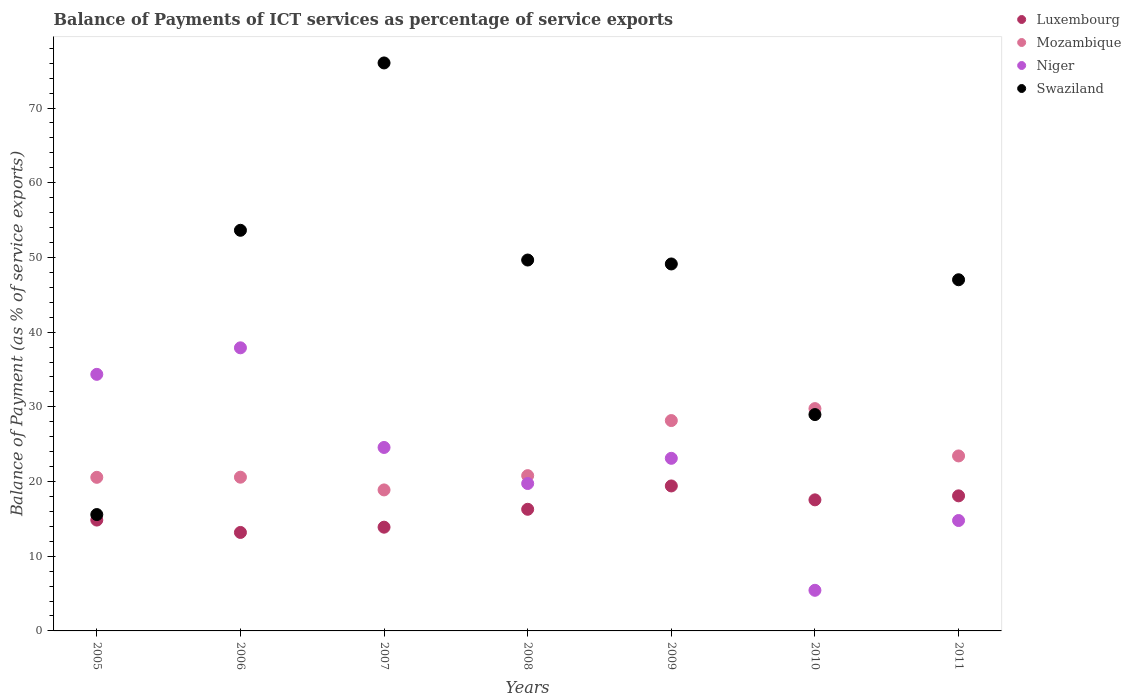What is the balance of payments of ICT services in Mozambique in 2005?
Your answer should be compact. 20.56. Across all years, what is the maximum balance of payments of ICT services in Niger?
Your answer should be very brief. 37.9. Across all years, what is the minimum balance of payments of ICT services in Mozambique?
Offer a terse response. 18.88. In which year was the balance of payments of ICT services in Swaziland minimum?
Ensure brevity in your answer.  2005. What is the total balance of payments of ICT services in Swaziland in the graph?
Ensure brevity in your answer.  319.99. What is the difference between the balance of payments of ICT services in Niger in 2008 and that in 2009?
Offer a terse response. -3.37. What is the difference between the balance of payments of ICT services in Luxembourg in 2011 and the balance of payments of ICT services in Swaziland in 2009?
Your answer should be very brief. -31.04. What is the average balance of payments of ICT services in Mozambique per year?
Offer a terse response. 23.16. In the year 2005, what is the difference between the balance of payments of ICT services in Luxembourg and balance of payments of ICT services in Mozambique?
Keep it short and to the point. -5.72. What is the ratio of the balance of payments of ICT services in Mozambique in 2006 to that in 2010?
Provide a short and direct response. 0.69. Is the difference between the balance of payments of ICT services in Luxembourg in 2006 and 2007 greater than the difference between the balance of payments of ICT services in Mozambique in 2006 and 2007?
Make the answer very short. No. What is the difference between the highest and the second highest balance of payments of ICT services in Mozambique?
Offer a terse response. 1.6. What is the difference between the highest and the lowest balance of payments of ICT services in Mozambique?
Offer a terse response. 10.88. Is the sum of the balance of payments of ICT services in Luxembourg in 2006 and 2009 greater than the maximum balance of payments of ICT services in Mozambique across all years?
Offer a terse response. Yes. Is it the case that in every year, the sum of the balance of payments of ICT services in Mozambique and balance of payments of ICT services in Luxembourg  is greater than the balance of payments of ICT services in Niger?
Your response must be concise. No. Does the balance of payments of ICT services in Swaziland monotonically increase over the years?
Offer a very short reply. No. How many dotlines are there?
Provide a succinct answer. 4. How many years are there in the graph?
Keep it short and to the point. 7. What is the difference between two consecutive major ticks on the Y-axis?
Your response must be concise. 10. Does the graph contain any zero values?
Your answer should be compact. No. Where does the legend appear in the graph?
Make the answer very short. Top right. How many legend labels are there?
Provide a succinct answer. 4. What is the title of the graph?
Give a very brief answer. Balance of Payments of ICT services as percentage of service exports. Does "Iran" appear as one of the legend labels in the graph?
Your response must be concise. No. What is the label or title of the X-axis?
Make the answer very short. Years. What is the label or title of the Y-axis?
Offer a terse response. Balance of Payment (as % of service exports). What is the Balance of Payment (as % of service exports) in Luxembourg in 2005?
Offer a very short reply. 14.84. What is the Balance of Payment (as % of service exports) in Mozambique in 2005?
Your response must be concise. 20.56. What is the Balance of Payment (as % of service exports) in Niger in 2005?
Your answer should be compact. 34.35. What is the Balance of Payment (as % of service exports) in Swaziland in 2005?
Provide a succinct answer. 15.58. What is the Balance of Payment (as % of service exports) in Luxembourg in 2006?
Provide a short and direct response. 13.18. What is the Balance of Payment (as % of service exports) of Mozambique in 2006?
Ensure brevity in your answer.  20.58. What is the Balance of Payment (as % of service exports) in Niger in 2006?
Ensure brevity in your answer.  37.9. What is the Balance of Payment (as % of service exports) of Swaziland in 2006?
Offer a very short reply. 53.63. What is the Balance of Payment (as % of service exports) of Luxembourg in 2007?
Provide a short and direct response. 13.89. What is the Balance of Payment (as % of service exports) of Mozambique in 2007?
Make the answer very short. 18.88. What is the Balance of Payment (as % of service exports) of Niger in 2007?
Make the answer very short. 24.56. What is the Balance of Payment (as % of service exports) of Swaziland in 2007?
Your response must be concise. 76.03. What is the Balance of Payment (as % of service exports) of Luxembourg in 2008?
Keep it short and to the point. 16.28. What is the Balance of Payment (as % of service exports) of Mozambique in 2008?
Keep it short and to the point. 20.79. What is the Balance of Payment (as % of service exports) of Niger in 2008?
Offer a terse response. 19.73. What is the Balance of Payment (as % of service exports) of Swaziland in 2008?
Keep it short and to the point. 49.65. What is the Balance of Payment (as % of service exports) in Luxembourg in 2009?
Ensure brevity in your answer.  19.41. What is the Balance of Payment (as % of service exports) of Mozambique in 2009?
Make the answer very short. 28.16. What is the Balance of Payment (as % of service exports) of Niger in 2009?
Make the answer very short. 23.11. What is the Balance of Payment (as % of service exports) in Swaziland in 2009?
Give a very brief answer. 49.12. What is the Balance of Payment (as % of service exports) of Luxembourg in 2010?
Your response must be concise. 17.55. What is the Balance of Payment (as % of service exports) of Mozambique in 2010?
Ensure brevity in your answer.  29.76. What is the Balance of Payment (as % of service exports) in Niger in 2010?
Give a very brief answer. 5.44. What is the Balance of Payment (as % of service exports) in Swaziland in 2010?
Your answer should be compact. 28.96. What is the Balance of Payment (as % of service exports) in Luxembourg in 2011?
Provide a succinct answer. 18.08. What is the Balance of Payment (as % of service exports) of Mozambique in 2011?
Keep it short and to the point. 23.43. What is the Balance of Payment (as % of service exports) in Niger in 2011?
Your answer should be compact. 14.78. What is the Balance of Payment (as % of service exports) of Swaziland in 2011?
Offer a terse response. 47.01. Across all years, what is the maximum Balance of Payment (as % of service exports) in Luxembourg?
Offer a very short reply. 19.41. Across all years, what is the maximum Balance of Payment (as % of service exports) of Mozambique?
Ensure brevity in your answer.  29.76. Across all years, what is the maximum Balance of Payment (as % of service exports) of Niger?
Keep it short and to the point. 37.9. Across all years, what is the maximum Balance of Payment (as % of service exports) in Swaziland?
Provide a succinct answer. 76.03. Across all years, what is the minimum Balance of Payment (as % of service exports) of Luxembourg?
Keep it short and to the point. 13.18. Across all years, what is the minimum Balance of Payment (as % of service exports) of Mozambique?
Offer a very short reply. 18.88. Across all years, what is the minimum Balance of Payment (as % of service exports) of Niger?
Provide a short and direct response. 5.44. Across all years, what is the minimum Balance of Payment (as % of service exports) in Swaziland?
Your answer should be very brief. 15.58. What is the total Balance of Payment (as % of service exports) of Luxembourg in the graph?
Provide a short and direct response. 113.23. What is the total Balance of Payment (as % of service exports) of Mozambique in the graph?
Your answer should be very brief. 162.15. What is the total Balance of Payment (as % of service exports) of Niger in the graph?
Your response must be concise. 159.86. What is the total Balance of Payment (as % of service exports) in Swaziland in the graph?
Offer a terse response. 319.99. What is the difference between the Balance of Payment (as % of service exports) in Luxembourg in 2005 and that in 2006?
Your answer should be compact. 1.66. What is the difference between the Balance of Payment (as % of service exports) in Mozambique in 2005 and that in 2006?
Give a very brief answer. -0.02. What is the difference between the Balance of Payment (as % of service exports) in Niger in 2005 and that in 2006?
Your answer should be very brief. -3.55. What is the difference between the Balance of Payment (as % of service exports) of Swaziland in 2005 and that in 2006?
Your answer should be compact. -38.05. What is the difference between the Balance of Payment (as % of service exports) in Luxembourg in 2005 and that in 2007?
Provide a succinct answer. 0.95. What is the difference between the Balance of Payment (as % of service exports) of Mozambique in 2005 and that in 2007?
Offer a very short reply. 1.69. What is the difference between the Balance of Payment (as % of service exports) of Niger in 2005 and that in 2007?
Provide a short and direct response. 9.79. What is the difference between the Balance of Payment (as % of service exports) in Swaziland in 2005 and that in 2007?
Make the answer very short. -60.46. What is the difference between the Balance of Payment (as % of service exports) in Luxembourg in 2005 and that in 2008?
Give a very brief answer. -1.44. What is the difference between the Balance of Payment (as % of service exports) in Mozambique in 2005 and that in 2008?
Keep it short and to the point. -0.22. What is the difference between the Balance of Payment (as % of service exports) of Niger in 2005 and that in 2008?
Your answer should be very brief. 14.61. What is the difference between the Balance of Payment (as % of service exports) of Swaziland in 2005 and that in 2008?
Provide a succinct answer. -34.07. What is the difference between the Balance of Payment (as % of service exports) of Luxembourg in 2005 and that in 2009?
Your answer should be compact. -4.57. What is the difference between the Balance of Payment (as % of service exports) of Mozambique in 2005 and that in 2009?
Make the answer very short. -7.6. What is the difference between the Balance of Payment (as % of service exports) in Niger in 2005 and that in 2009?
Offer a very short reply. 11.24. What is the difference between the Balance of Payment (as % of service exports) in Swaziland in 2005 and that in 2009?
Offer a very short reply. -33.55. What is the difference between the Balance of Payment (as % of service exports) of Luxembourg in 2005 and that in 2010?
Offer a terse response. -2.71. What is the difference between the Balance of Payment (as % of service exports) in Mozambique in 2005 and that in 2010?
Keep it short and to the point. -9.2. What is the difference between the Balance of Payment (as % of service exports) in Niger in 2005 and that in 2010?
Make the answer very short. 28.91. What is the difference between the Balance of Payment (as % of service exports) in Swaziland in 2005 and that in 2010?
Ensure brevity in your answer.  -13.38. What is the difference between the Balance of Payment (as % of service exports) of Luxembourg in 2005 and that in 2011?
Keep it short and to the point. -3.24. What is the difference between the Balance of Payment (as % of service exports) in Mozambique in 2005 and that in 2011?
Offer a terse response. -2.86. What is the difference between the Balance of Payment (as % of service exports) in Niger in 2005 and that in 2011?
Keep it short and to the point. 19.57. What is the difference between the Balance of Payment (as % of service exports) of Swaziland in 2005 and that in 2011?
Provide a short and direct response. -31.43. What is the difference between the Balance of Payment (as % of service exports) of Luxembourg in 2006 and that in 2007?
Your answer should be very brief. -0.7. What is the difference between the Balance of Payment (as % of service exports) of Mozambique in 2006 and that in 2007?
Offer a very short reply. 1.7. What is the difference between the Balance of Payment (as % of service exports) of Niger in 2006 and that in 2007?
Offer a very short reply. 13.34. What is the difference between the Balance of Payment (as % of service exports) in Swaziland in 2006 and that in 2007?
Offer a very short reply. -22.4. What is the difference between the Balance of Payment (as % of service exports) in Luxembourg in 2006 and that in 2008?
Give a very brief answer. -3.1. What is the difference between the Balance of Payment (as % of service exports) of Mozambique in 2006 and that in 2008?
Keep it short and to the point. -0.21. What is the difference between the Balance of Payment (as % of service exports) in Niger in 2006 and that in 2008?
Your response must be concise. 18.16. What is the difference between the Balance of Payment (as % of service exports) of Swaziland in 2006 and that in 2008?
Your answer should be very brief. 3.98. What is the difference between the Balance of Payment (as % of service exports) in Luxembourg in 2006 and that in 2009?
Keep it short and to the point. -6.22. What is the difference between the Balance of Payment (as % of service exports) of Mozambique in 2006 and that in 2009?
Give a very brief answer. -7.58. What is the difference between the Balance of Payment (as % of service exports) in Niger in 2006 and that in 2009?
Your answer should be very brief. 14.79. What is the difference between the Balance of Payment (as % of service exports) of Swaziland in 2006 and that in 2009?
Make the answer very short. 4.51. What is the difference between the Balance of Payment (as % of service exports) of Luxembourg in 2006 and that in 2010?
Give a very brief answer. -4.36. What is the difference between the Balance of Payment (as % of service exports) of Mozambique in 2006 and that in 2010?
Your answer should be compact. -9.18. What is the difference between the Balance of Payment (as % of service exports) of Niger in 2006 and that in 2010?
Provide a short and direct response. 32.46. What is the difference between the Balance of Payment (as % of service exports) of Swaziland in 2006 and that in 2010?
Make the answer very short. 24.67. What is the difference between the Balance of Payment (as % of service exports) in Luxembourg in 2006 and that in 2011?
Give a very brief answer. -4.9. What is the difference between the Balance of Payment (as % of service exports) of Mozambique in 2006 and that in 2011?
Keep it short and to the point. -2.85. What is the difference between the Balance of Payment (as % of service exports) of Niger in 2006 and that in 2011?
Provide a short and direct response. 23.12. What is the difference between the Balance of Payment (as % of service exports) of Swaziland in 2006 and that in 2011?
Your answer should be very brief. 6.62. What is the difference between the Balance of Payment (as % of service exports) in Luxembourg in 2007 and that in 2008?
Keep it short and to the point. -2.4. What is the difference between the Balance of Payment (as % of service exports) in Mozambique in 2007 and that in 2008?
Ensure brevity in your answer.  -1.91. What is the difference between the Balance of Payment (as % of service exports) in Niger in 2007 and that in 2008?
Provide a short and direct response. 4.83. What is the difference between the Balance of Payment (as % of service exports) in Swaziland in 2007 and that in 2008?
Give a very brief answer. 26.38. What is the difference between the Balance of Payment (as % of service exports) in Luxembourg in 2007 and that in 2009?
Provide a short and direct response. -5.52. What is the difference between the Balance of Payment (as % of service exports) of Mozambique in 2007 and that in 2009?
Give a very brief answer. -9.28. What is the difference between the Balance of Payment (as % of service exports) in Niger in 2007 and that in 2009?
Your response must be concise. 1.45. What is the difference between the Balance of Payment (as % of service exports) in Swaziland in 2007 and that in 2009?
Give a very brief answer. 26.91. What is the difference between the Balance of Payment (as % of service exports) in Luxembourg in 2007 and that in 2010?
Offer a terse response. -3.66. What is the difference between the Balance of Payment (as % of service exports) of Mozambique in 2007 and that in 2010?
Keep it short and to the point. -10.88. What is the difference between the Balance of Payment (as % of service exports) in Niger in 2007 and that in 2010?
Offer a terse response. 19.12. What is the difference between the Balance of Payment (as % of service exports) in Swaziland in 2007 and that in 2010?
Your response must be concise. 47.07. What is the difference between the Balance of Payment (as % of service exports) of Luxembourg in 2007 and that in 2011?
Offer a very short reply. -4.2. What is the difference between the Balance of Payment (as % of service exports) in Mozambique in 2007 and that in 2011?
Your answer should be compact. -4.55. What is the difference between the Balance of Payment (as % of service exports) in Niger in 2007 and that in 2011?
Offer a terse response. 9.78. What is the difference between the Balance of Payment (as % of service exports) of Swaziland in 2007 and that in 2011?
Provide a succinct answer. 29.02. What is the difference between the Balance of Payment (as % of service exports) of Luxembourg in 2008 and that in 2009?
Your answer should be very brief. -3.12. What is the difference between the Balance of Payment (as % of service exports) of Mozambique in 2008 and that in 2009?
Your answer should be very brief. -7.37. What is the difference between the Balance of Payment (as % of service exports) of Niger in 2008 and that in 2009?
Give a very brief answer. -3.37. What is the difference between the Balance of Payment (as % of service exports) in Swaziland in 2008 and that in 2009?
Offer a terse response. 0.53. What is the difference between the Balance of Payment (as % of service exports) of Luxembourg in 2008 and that in 2010?
Offer a very short reply. -1.26. What is the difference between the Balance of Payment (as % of service exports) in Mozambique in 2008 and that in 2010?
Make the answer very short. -8.97. What is the difference between the Balance of Payment (as % of service exports) of Niger in 2008 and that in 2010?
Your answer should be very brief. 14.3. What is the difference between the Balance of Payment (as % of service exports) in Swaziland in 2008 and that in 2010?
Keep it short and to the point. 20.69. What is the difference between the Balance of Payment (as % of service exports) of Luxembourg in 2008 and that in 2011?
Provide a succinct answer. -1.8. What is the difference between the Balance of Payment (as % of service exports) in Mozambique in 2008 and that in 2011?
Your answer should be very brief. -2.64. What is the difference between the Balance of Payment (as % of service exports) of Niger in 2008 and that in 2011?
Your answer should be very brief. 4.95. What is the difference between the Balance of Payment (as % of service exports) of Swaziland in 2008 and that in 2011?
Offer a very short reply. 2.64. What is the difference between the Balance of Payment (as % of service exports) of Luxembourg in 2009 and that in 2010?
Give a very brief answer. 1.86. What is the difference between the Balance of Payment (as % of service exports) of Mozambique in 2009 and that in 2010?
Your answer should be very brief. -1.6. What is the difference between the Balance of Payment (as % of service exports) of Niger in 2009 and that in 2010?
Your answer should be very brief. 17.67. What is the difference between the Balance of Payment (as % of service exports) of Swaziland in 2009 and that in 2010?
Your response must be concise. 20.16. What is the difference between the Balance of Payment (as % of service exports) of Luxembourg in 2009 and that in 2011?
Your answer should be compact. 1.33. What is the difference between the Balance of Payment (as % of service exports) of Mozambique in 2009 and that in 2011?
Give a very brief answer. 4.73. What is the difference between the Balance of Payment (as % of service exports) in Niger in 2009 and that in 2011?
Make the answer very short. 8.33. What is the difference between the Balance of Payment (as % of service exports) in Swaziland in 2009 and that in 2011?
Ensure brevity in your answer.  2.11. What is the difference between the Balance of Payment (as % of service exports) in Luxembourg in 2010 and that in 2011?
Offer a terse response. -0.54. What is the difference between the Balance of Payment (as % of service exports) of Mozambique in 2010 and that in 2011?
Your response must be concise. 6.34. What is the difference between the Balance of Payment (as % of service exports) of Niger in 2010 and that in 2011?
Your response must be concise. -9.34. What is the difference between the Balance of Payment (as % of service exports) of Swaziland in 2010 and that in 2011?
Offer a very short reply. -18.05. What is the difference between the Balance of Payment (as % of service exports) in Luxembourg in 2005 and the Balance of Payment (as % of service exports) in Mozambique in 2006?
Make the answer very short. -5.74. What is the difference between the Balance of Payment (as % of service exports) of Luxembourg in 2005 and the Balance of Payment (as % of service exports) of Niger in 2006?
Your answer should be very brief. -23.06. What is the difference between the Balance of Payment (as % of service exports) of Luxembourg in 2005 and the Balance of Payment (as % of service exports) of Swaziland in 2006?
Ensure brevity in your answer.  -38.79. What is the difference between the Balance of Payment (as % of service exports) in Mozambique in 2005 and the Balance of Payment (as % of service exports) in Niger in 2006?
Offer a very short reply. -17.34. What is the difference between the Balance of Payment (as % of service exports) of Mozambique in 2005 and the Balance of Payment (as % of service exports) of Swaziland in 2006?
Your response must be concise. -33.07. What is the difference between the Balance of Payment (as % of service exports) of Niger in 2005 and the Balance of Payment (as % of service exports) of Swaziland in 2006?
Your response must be concise. -19.28. What is the difference between the Balance of Payment (as % of service exports) of Luxembourg in 2005 and the Balance of Payment (as % of service exports) of Mozambique in 2007?
Offer a terse response. -4.04. What is the difference between the Balance of Payment (as % of service exports) in Luxembourg in 2005 and the Balance of Payment (as % of service exports) in Niger in 2007?
Your answer should be very brief. -9.72. What is the difference between the Balance of Payment (as % of service exports) in Luxembourg in 2005 and the Balance of Payment (as % of service exports) in Swaziland in 2007?
Your answer should be compact. -61.2. What is the difference between the Balance of Payment (as % of service exports) in Mozambique in 2005 and the Balance of Payment (as % of service exports) in Niger in 2007?
Provide a succinct answer. -4. What is the difference between the Balance of Payment (as % of service exports) of Mozambique in 2005 and the Balance of Payment (as % of service exports) of Swaziland in 2007?
Make the answer very short. -55.47. What is the difference between the Balance of Payment (as % of service exports) in Niger in 2005 and the Balance of Payment (as % of service exports) in Swaziland in 2007?
Provide a short and direct response. -41.69. What is the difference between the Balance of Payment (as % of service exports) of Luxembourg in 2005 and the Balance of Payment (as % of service exports) of Mozambique in 2008?
Offer a very short reply. -5.95. What is the difference between the Balance of Payment (as % of service exports) of Luxembourg in 2005 and the Balance of Payment (as % of service exports) of Niger in 2008?
Provide a short and direct response. -4.89. What is the difference between the Balance of Payment (as % of service exports) in Luxembourg in 2005 and the Balance of Payment (as % of service exports) in Swaziland in 2008?
Provide a succinct answer. -34.81. What is the difference between the Balance of Payment (as % of service exports) of Mozambique in 2005 and the Balance of Payment (as % of service exports) of Niger in 2008?
Provide a succinct answer. 0.83. What is the difference between the Balance of Payment (as % of service exports) of Mozambique in 2005 and the Balance of Payment (as % of service exports) of Swaziland in 2008?
Make the answer very short. -29.09. What is the difference between the Balance of Payment (as % of service exports) of Niger in 2005 and the Balance of Payment (as % of service exports) of Swaziland in 2008?
Provide a succinct answer. -15.3. What is the difference between the Balance of Payment (as % of service exports) in Luxembourg in 2005 and the Balance of Payment (as % of service exports) in Mozambique in 2009?
Your response must be concise. -13.32. What is the difference between the Balance of Payment (as % of service exports) of Luxembourg in 2005 and the Balance of Payment (as % of service exports) of Niger in 2009?
Your answer should be very brief. -8.27. What is the difference between the Balance of Payment (as % of service exports) in Luxembourg in 2005 and the Balance of Payment (as % of service exports) in Swaziland in 2009?
Offer a terse response. -34.28. What is the difference between the Balance of Payment (as % of service exports) in Mozambique in 2005 and the Balance of Payment (as % of service exports) in Niger in 2009?
Your answer should be very brief. -2.54. What is the difference between the Balance of Payment (as % of service exports) in Mozambique in 2005 and the Balance of Payment (as % of service exports) in Swaziland in 2009?
Give a very brief answer. -28.56. What is the difference between the Balance of Payment (as % of service exports) in Niger in 2005 and the Balance of Payment (as % of service exports) in Swaziland in 2009?
Your answer should be compact. -14.78. What is the difference between the Balance of Payment (as % of service exports) of Luxembourg in 2005 and the Balance of Payment (as % of service exports) of Mozambique in 2010?
Your answer should be very brief. -14.92. What is the difference between the Balance of Payment (as % of service exports) of Luxembourg in 2005 and the Balance of Payment (as % of service exports) of Niger in 2010?
Offer a terse response. 9.4. What is the difference between the Balance of Payment (as % of service exports) of Luxembourg in 2005 and the Balance of Payment (as % of service exports) of Swaziland in 2010?
Your answer should be compact. -14.12. What is the difference between the Balance of Payment (as % of service exports) of Mozambique in 2005 and the Balance of Payment (as % of service exports) of Niger in 2010?
Give a very brief answer. 15.12. What is the difference between the Balance of Payment (as % of service exports) of Mozambique in 2005 and the Balance of Payment (as % of service exports) of Swaziland in 2010?
Make the answer very short. -8.4. What is the difference between the Balance of Payment (as % of service exports) in Niger in 2005 and the Balance of Payment (as % of service exports) in Swaziland in 2010?
Offer a terse response. 5.38. What is the difference between the Balance of Payment (as % of service exports) of Luxembourg in 2005 and the Balance of Payment (as % of service exports) of Mozambique in 2011?
Your response must be concise. -8.59. What is the difference between the Balance of Payment (as % of service exports) of Luxembourg in 2005 and the Balance of Payment (as % of service exports) of Niger in 2011?
Ensure brevity in your answer.  0.06. What is the difference between the Balance of Payment (as % of service exports) of Luxembourg in 2005 and the Balance of Payment (as % of service exports) of Swaziland in 2011?
Provide a short and direct response. -32.17. What is the difference between the Balance of Payment (as % of service exports) in Mozambique in 2005 and the Balance of Payment (as % of service exports) in Niger in 2011?
Offer a terse response. 5.78. What is the difference between the Balance of Payment (as % of service exports) in Mozambique in 2005 and the Balance of Payment (as % of service exports) in Swaziland in 2011?
Your answer should be very brief. -26.45. What is the difference between the Balance of Payment (as % of service exports) of Niger in 2005 and the Balance of Payment (as % of service exports) of Swaziland in 2011?
Your answer should be compact. -12.66. What is the difference between the Balance of Payment (as % of service exports) of Luxembourg in 2006 and the Balance of Payment (as % of service exports) of Mozambique in 2007?
Ensure brevity in your answer.  -5.69. What is the difference between the Balance of Payment (as % of service exports) of Luxembourg in 2006 and the Balance of Payment (as % of service exports) of Niger in 2007?
Your answer should be very brief. -11.38. What is the difference between the Balance of Payment (as % of service exports) of Luxembourg in 2006 and the Balance of Payment (as % of service exports) of Swaziland in 2007?
Your answer should be compact. -62.85. What is the difference between the Balance of Payment (as % of service exports) in Mozambique in 2006 and the Balance of Payment (as % of service exports) in Niger in 2007?
Ensure brevity in your answer.  -3.98. What is the difference between the Balance of Payment (as % of service exports) of Mozambique in 2006 and the Balance of Payment (as % of service exports) of Swaziland in 2007?
Offer a very short reply. -55.46. What is the difference between the Balance of Payment (as % of service exports) of Niger in 2006 and the Balance of Payment (as % of service exports) of Swaziland in 2007?
Offer a very short reply. -38.14. What is the difference between the Balance of Payment (as % of service exports) in Luxembourg in 2006 and the Balance of Payment (as % of service exports) in Mozambique in 2008?
Your answer should be very brief. -7.6. What is the difference between the Balance of Payment (as % of service exports) of Luxembourg in 2006 and the Balance of Payment (as % of service exports) of Niger in 2008?
Your answer should be compact. -6.55. What is the difference between the Balance of Payment (as % of service exports) of Luxembourg in 2006 and the Balance of Payment (as % of service exports) of Swaziland in 2008?
Your answer should be very brief. -36.47. What is the difference between the Balance of Payment (as % of service exports) of Mozambique in 2006 and the Balance of Payment (as % of service exports) of Niger in 2008?
Keep it short and to the point. 0.85. What is the difference between the Balance of Payment (as % of service exports) of Mozambique in 2006 and the Balance of Payment (as % of service exports) of Swaziland in 2008?
Your answer should be very brief. -29.07. What is the difference between the Balance of Payment (as % of service exports) in Niger in 2006 and the Balance of Payment (as % of service exports) in Swaziland in 2008?
Keep it short and to the point. -11.75. What is the difference between the Balance of Payment (as % of service exports) in Luxembourg in 2006 and the Balance of Payment (as % of service exports) in Mozambique in 2009?
Your answer should be compact. -14.98. What is the difference between the Balance of Payment (as % of service exports) in Luxembourg in 2006 and the Balance of Payment (as % of service exports) in Niger in 2009?
Your response must be concise. -9.92. What is the difference between the Balance of Payment (as % of service exports) of Luxembourg in 2006 and the Balance of Payment (as % of service exports) of Swaziland in 2009?
Offer a very short reply. -35.94. What is the difference between the Balance of Payment (as % of service exports) in Mozambique in 2006 and the Balance of Payment (as % of service exports) in Niger in 2009?
Offer a terse response. -2.53. What is the difference between the Balance of Payment (as % of service exports) in Mozambique in 2006 and the Balance of Payment (as % of service exports) in Swaziland in 2009?
Keep it short and to the point. -28.54. What is the difference between the Balance of Payment (as % of service exports) of Niger in 2006 and the Balance of Payment (as % of service exports) of Swaziland in 2009?
Keep it short and to the point. -11.23. What is the difference between the Balance of Payment (as % of service exports) of Luxembourg in 2006 and the Balance of Payment (as % of service exports) of Mozambique in 2010?
Your answer should be compact. -16.58. What is the difference between the Balance of Payment (as % of service exports) in Luxembourg in 2006 and the Balance of Payment (as % of service exports) in Niger in 2010?
Keep it short and to the point. 7.74. What is the difference between the Balance of Payment (as % of service exports) of Luxembourg in 2006 and the Balance of Payment (as % of service exports) of Swaziland in 2010?
Make the answer very short. -15.78. What is the difference between the Balance of Payment (as % of service exports) of Mozambique in 2006 and the Balance of Payment (as % of service exports) of Niger in 2010?
Give a very brief answer. 15.14. What is the difference between the Balance of Payment (as % of service exports) in Mozambique in 2006 and the Balance of Payment (as % of service exports) in Swaziland in 2010?
Provide a succinct answer. -8.38. What is the difference between the Balance of Payment (as % of service exports) in Niger in 2006 and the Balance of Payment (as % of service exports) in Swaziland in 2010?
Give a very brief answer. 8.93. What is the difference between the Balance of Payment (as % of service exports) in Luxembourg in 2006 and the Balance of Payment (as % of service exports) in Mozambique in 2011?
Offer a terse response. -10.24. What is the difference between the Balance of Payment (as % of service exports) in Luxembourg in 2006 and the Balance of Payment (as % of service exports) in Niger in 2011?
Make the answer very short. -1.6. What is the difference between the Balance of Payment (as % of service exports) of Luxembourg in 2006 and the Balance of Payment (as % of service exports) of Swaziland in 2011?
Provide a short and direct response. -33.83. What is the difference between the Balance of Payment (as % of service exports) in Mozambique in 2006 and the Balance of Payment (as % of service exports) in Niger in 2011?
Provide a succinct answer. 5.8. What is the difference between the Balance of Payment (as % of service exports) of Mozambique in 2006 and the Balance of Payment (as % of service exports) of Swaziland in 2011?
Provide a short and direct response. -26.43. What is the difference between the Balance of Payment (as % of service exports) of Niger in 2006 and the Balance of Payment (as % of service exports) of Swaziland in 2011?
Ensure brevity in your answer.  -9.11. What is the difference between the Balance of Payment (as % of service exports) in Luxembourg in 2007 and the Balance of Payment (as % of service exports) in Mozambique in 2008?
Keep it short and to the point. -6.9. What is the difference between the Balance of Payment (as % of service exports) of Luxembourg in 2007 and the Balance of Payment (as % of service exports) of Niger in 2008?
Your answer should be compact. -5.85. What is the difference between the Balance of Payment (as % of service exports) in Luxembourg in 2007 and the Balance of Payment (as % of service exports) in Swaziland in 2008?
Your answer should be very brief. -35.76. What is the difference between the Balance of Payment (as % of service exports) in Mozambique in 2007 and the Balance of Payment (as % of service exports) in Niger in 2008?
Keep it short and to the point. -0.86. What is the difference between the Balance of Payment (as % of service exports) in Mozambique in 2007 and the Balance of Payment (as % of service exports) in Swaziland in 2008?
Provide a short and direct response. -30.78. What is the difference between the Balance of Payment (as % of service exports) of Niger in 2007 and the Balance of Payment (as % of service exports) of Swaziland in 2008?
Offer a terse response. -25.09. What is the difference between the Balance of Payment (as % of service exports) of Luxembourg in 2007 and the Balance of Payment (as % of service exports) of Mozambique in 2009?
Make the answer very short. -14.27. What is the difference between the Balance of Payment (as % of service exports) of Luxembourg in 2007 and the Balance of Payment (as % of service exports) of Niger in 2009?
Your answer should be compact. -9.22. What is the difference between the Balance of Payment (as % of service exports) in Luxembourg in 2007 and the Balance of Payment (as % of service exports) in Swaziland in 2009?
Offer a terse response. -35.24. What is the difference between the Balance of Payment (as % of service exports) of Mozambique in 2007 and the Balance of Payment (as % of service exports) of Niger in 2009?
Give a very brief answer. -4.23. What is the difference between the Balance of Payment (as % of service exports) in Mozambique in 2007 and the Balance of Payment (as % of service exports) in Swaziland in 2009?
Give a very brief answer. -30.25. What is the difference between the Balance of Payment (as % of service exports) in Niger in 2007 and the Balance of Payment (as % of service exports) in Swaziland in 2009?
Provide a succinct answer. -24.56. What is the difference between the Balance of Payment (as % of service exports) of Luxembourg in 2007 and the Balance of Payment (as % of service exports) of Mozambique in 2010?
Provide a succinct answer. -15.87. What is the difference between the Balance of Payment (as % of service exports) of Luxembourg in 2007 and the Balance of Payment (as % of service exports) of Niger in 2010?
Offer a terse response. 8.45. What is the difference between the Balance of Payment (as % of service exports) in Luxembourg in 2007 and the Balance of Payment (as % of service exports) in Swaziland in 2010?
Ensure brevity in your answer.  -15.08. What is the difference between the Balance of Payment (as % of service exports) of Mozambique in 2007 and the Balance of Payment (as % of service exports) of Niger in 2010?
Your response must be concise. 13.44. What is the difference between the Balance of Payment (as % of service exports) of Mozambique in 2007 and the Balance of Payment (as % of service exports) of Swaziland in 2010?
Provide a short and direct response. -10.09. What is the difference between the Balance of Payment (as % of service exports) of Niger in 2007 and the Balance of Payment (as % of service exports) of Swaziland in 2010?
Your response must be concise. -4.4. What is the difference between the Balance of Payment (as % of service exports) in Luxembourg in 2007 and the Balance of Payment (as % of service exports) in Mozambique in 2011?
Provide a short and direct response. -9.54. What is the difference between the Balance of Payment (as % of service exports) of Luxembourg in 2007 and the Balance of Payment (as % of service exports) of Niger in 2011?
Your answer should be compact. -0.89. What is the difference between the Balance of Payment (as % of service exports) of Luxembourg in 2007 and the Balance of Payment (as % of service exports) of Swaziland in 2011?
Keep it short and to the point. -33.12. What is the difference between the Balance of Payment (as % of service exports) in Mozambique in 2007 and the Balance of Payment (as % of service exports) in Niger in 2011?
Offer a terse response. 4.1. What is the difference between the Balance of Payment (as % of service exports) in Mozambique in 2007 and the Balance of Payment (as % of service exports) in Swaziland in 2011?
Keep it short and to the point. -28.14. What is the difference between the Balance of Payment (as % of service exports) of Niger in 2007 and the Balance of Payment (as % of service exports) of Swaziland in 2011?
Keep it short and to the point. -22.45. What is the difference between the Balance of Payment (as % of service exports) in Luxembourg in 2008 and the Balance of Payment (as % of service exports) in Mozambique in 2009?
Make the answer very short. -11.88. What is the difference between the Balance of Payment (as % of service exports) in Luxembourg in 2008 and the Balance of Payment (as % of service exports) in Niger in 2009?
Offer a very short reply. -6.82. What is the difference between the Balance of Payment (as % of service exports) of Luxembourg in 2008 and the Balance of Payment (as % of service exports) of Swaziland in 2009?
Provide a short and direct response. -32.84. What is the difference between the Balance of Payment (as % of service exports) in Mozambique in 2008 and the Balance of Payment (as % of service exports) in Niger in 2009?
Provide a short and direct response. -2.32. What is the difference between the Balance of Payment (as % of service exports) in Mozambique in 2008 and the Balance of Payment (as % of service exports) in Swaziland in 2009?
Offer a very short reply. -28.34. What is the difference between the Balance of Payment (as % of service exports) in Niger in 2008 and the Balance of Payment (as % of service exports) in Swaziland in 2009?
Your answer should be very brief. -29.39. What is the difference between the Balance of Payment (as % of service exports) in Luxembourg in 2008 and the Balance of Payment (as % of service exports) in Mozambique in 2010?
Your response must be concise. -13.48. What is the difference between the Balance of Payment (as % of service exports) in Luxembourg in 2008 and the Balance of Payment (as % of service exports) in Niger in 2010?
Provide a succinct answer. 10.85. What is the difference between the Balance of Payment (as % of service exports) of Luxembourg in 2008 and the Balance of Payment (as % of service exports) of Swaziland in 2010?
Keep it short and to the point. -12.68. What is the difference between the Balance of Payment (as % of service exports) of Mozambique in 2008 and the Balance of Payment (as % of service exports) of Niger in 2010?
Provide a short and direct response. 15.35. What is the difference between the Balance of Payment (as % of service exports) of Mozambique in 2008 and the Balance of Payment (as % of service exports) of Swaziland in 2010?
Make the answer very short. -8.18. What is the difference between the Balance of Payment (as % of service exports) in Niger in 2008 and the Balance of Payment (as % of service exports) in Swaziland in 2010?
Your answer should be very brief. -9.23. What is the difference between the Balance of Payment (as % of service exports) in Luxembourg in 2008 and the Balance of Payment (as % of service exports) in Mozambique in 2011?
Your answer should be very brief. -7.14. What is the difference between the Balance of Payment (as % of service exports) in Luxembourg in 2008 and the Balance of Payment (as % of service exports) in Niger in 2011?
Give a very brief answer. 1.5. What is the difference between the Balance of Payment (as % of service exports) in Luxembourg in 2008 and the Balance of Payment (as % of service exports) in Swaziland in 2011?
Your answer should be very brief. -30.73. What is the difference between the Balance of Payment (as % of service exports) in Mozambique in 2008 and the Balance of Payment (as % of service exports) in Niger in 2011?
Keep it short and to the point. 6.01. What is the difference between the Balance of Payment (as % of service exports) of Mozambique in 2008 and the Balance of Payment (as % of service exports) of Swaziland in 2011?
Provide a short and direct response. -26.22. What is the difference between the Balance of Payment (as % of service exports) of Niger in 2008 and the Balance of Payment (as % of service exports) of Swaziland in 2011?
Your answer should be compact. -27.28. What is the difference between the Balance of Payment (as % of service exports) in Luxembourg in 2009 and the Balance of Payment (as % of service exports) in Mozambique in 2010?
Provide a succinct answer. -10.35. What is the difference between the Balance of Payment (as % of service exports) of Luxembourg in 2009 and the Balance of Payment (as % of service exports) of Niger in 2010?
Keep it short and to the point. 13.97. What is the difference between the Balance of Payment (as % of service exports) in Luxembourg in 2009 and the Balance of Payment (as % of service exports) in Swaziland in 2010?
Make the answer very short. -9.56. What is the difference between the Balance of Payment (as % of service exports) of Mozambique in 2009 and the Balance of Payment (as % of service exports) of Niger in 2010?
Your answer should be compact. 22.72. What is the difference between the Balance of Payment (as % of service exports) of Mozambique in 2009 and the Balance of Payment (as % of service exports) of Swaziland in 2010?
Give a very brief answer. -0.8. What is the difference between the Balance of Payment (as % of service exports) of Niger in 2009 and the Balance of Payment (as % of service exports) of Swaziland in 2010?
Give a very brief answer. -5.86. What is the difference between the Balance of Payment (as % of service exports) in Luxembourg in 2009 and the Balance of Payment (as % of service exports) in Mozambique in 2011?
Your answer should be compact. -4.02. What is the difference between the Balance of Payment (as % of service exports) of Luxembourg in 2009 and the Balance of Payment (as % of service exports) of Niger in 2011?
Your answer should be compact. 4.63. What is the difference between the Balance of Payment (as % of service exports) of Luxembourg in 2009 and the Balance of Payment (as % of service exports) of Swaziland in 2011?
Your answer should be very brief. -27.6. What is the difference between the Balance of Payment (as % of service exports) of Mozambique in 2009 and the Balance of Payment (as % of service exports) of Niger in 2011?
Give a very brief answer. 13.38. What is the difference between the Balance of Payment (as % of service exports) of Mozambique in 2009 and the Balance of Payment (as % of service exports) of Swaziland in 2011?
Ensure brevity in your answer.  -18.85. What is the difference between the Balance of Payment (as % of service exports) of Niger in 2009 and the Balance of Payment (as % of service exports) of Swaziland in 2011?
Make the answer very short. -23.9. What is the difference between the Balance of Payment (as % of service exports) in Luxembourg in 2010 and the Balance of Payment (as % of service exports) in Mozambique in 2011?
Provide a succinct answer. -5.88. What is the difference between the Balance of Payment (as % of service exports) in Luxembourg in 2010 and the Balance of Payment (as % of service exports) in Niger in 2011?
Provide a succinct answer. 2.77. What is the difference between the Balance of Payment (as % of service exports) of Luxembourg in 2010 and the Balance of Payment (as % of service exports) of Swaziland in 2011?
Give a very brief answer. -29.47. What is the difference between the Balance of Payment (as % of service exports) of Mozambique in 2010 and the Balance of Payment (as % of service exports) of Niger in 2011?
Keep it short and to the point. 14.98. What is the difference between the Balance of Payment (as % of service exports) of Mozambique in 2010 and the Balance of Payment (as % of service exports) of Swaziland in 2011?
Offer a terse response. -17.25. What is the difference between the Balance of Payment (as % of service exports) in Niger in 2010 and the Balance of Payment (as % of service exports) in Swaziland in 2011?
Make the answer very short. -41.57. What is the average Balance of Payment (as % of service exports) of Luxembourg per year?
Make the answer very short. 16.18. What is the average Balance of Payment (as % of service exports) of Mozambique per year?
Keep it short and to the point. 23.16. What is the average Balance of Payment (as % of service exports) in Niger per year?
Make the answer very short. 22.84. What is the average Balance of Payment (as % of service exports) of Swaziland per year?
Your answer should be compact. 45.71. In the year 2005, what is the difference between the Balance of Payment (as % of service exports) in Luxembourg and Balance of Payment (as % of service exports) in Mozambique?
Ensure brevity in your answer.  -5.72. In the year 2005, what is the difference between the Balance of Payment (as % of service exports) in Luxembourg and Balance of Payment (as % of service exports) in Niger?
Offer a very short reply. -19.51. In the year 2005, what is the difference between the Balance of Payment (as % of service exports) in Luxembourg and Balance of Payment (as % of service exports) in Swaziland?
Ensure brevity in your answer.  -0.74. In the year 2005, what is the difference between the Balance of Payment (as % of service exports) in Mozambique and Balance of Payment (as % of service exports) in Niger?
Provide a short and direct response. -13.79. In the year 2005, what is the difference between the Balance of Payment (as % of service exports) in Mozambique and Balance of Payment (as % of service exports) in Swaziland?
Provide a short and direct response. 4.98. In the year 2005, what is the difference between the Balance of Payment (as % of service exports) in Niger and Balance of Payment (as % of service exports) in Swaziland?
Your answer should be very brief. 18.77. In the year 2006, what is the difference between the Balance of Payment (as % of service exports) in Luxembourg and Balance of Payment (as % of service exports) in Mozambique?
Provide a short and direct response. -7.4. In the year 2006, what is the difference between the Balance of Payment (as % of service exports) in Luxembourg and Balance of Payment (as % of service exports) in Niger?
Your response must be concise. -24.72. In the year 2006, what is the difference between the Balance of Payment (as % of service exports) in Luxembourg and Balance of Payment (as % of service exports) in Swaziland?
Offer a terse response. -40.45. In the year 2006, what is the difference between the Balance of Payment (as % of service exports) of Mozambique and Balance of Payment (as % of service exports) of Niger?
Your answer should be very brief. -17.32. In the year 2006, what is the difference between the Balance of Payment (as % of service exports) of Mozambique and Balance of Payment (as % of service exports) of Swaziland?
Offer a terse response. -33.05. In the year 2006, what is the difference between the Balance of Payment (as % of service exports) of Niger and Balance of Payment (as % of service exports) of Swaziland?
Keep it short and to the point. -15.73. In the year 2007, what is the difference between the Balance of Payment (as % of service exports) of Luxembourg and Balance of Payment (as % of service exports) of Mozambique?
Your answer should be compact. -4.99. In the year 2007, what is the difference between the Balance of Payment (as % of service exports) of Luxembourg and Balance of Payment (as % of service exports) of Niger?
Keep it short and to the point. -10.67. In the year 2007, what is the difference between the Balance of Payment (as % of service exports) in Luxembourg and Balance of Payment (as % of service exports) in Swaziland?
Your answer should be compact. -62.15. In the year 2007, what is the difference between the Balance of Payment (as % of service exports) of Mozambique and Balance of Payment (as % of service exports) of Niger?
Your answer should be very brief. -5.68. In the year 2007, what is the difference between the Balance of Payment (as % of service exports) in Mozambique and Balance of Payment (as % of service exports) in Swaziland?
Offer a very short reply. -57.16. In the year 2007, what is the difference between the Balance of Payment (as % of service exports) in Niger and Balance of Payment (as % of service exports) in Swaziland?
Ensure brevity in your answer.  -51.47. In the year 2008, what is the difference between the Balance of Payment (as % of service exports) of Luxembourg and Balance of Payment (as % of service exports) of Mozambique?
Your response must be concise. -4.5. In the year 2008, what is the difference between the Balance of Payment (as % of service exports) of Luxembourg and Balance of Payment (as % of service exports) of Niger?
Provide a short and direct response. -3.45. In the year 2008, what is the difference between the Balance of Payment (as % of service exports) in Luxembourg and Balance of Payment (as % of service exports) in Swaziland?
Offer a very short reply. -33.37. In the year 2008, what is the difference between the Balance of Payment (as % of service exports) in Mozambique and Balance of Payment (as % of service exports) in Niger?
Give a very brief answer. 1.05. In the year 2008, what is the difference between the Balance of Payment (as % of service exports) of Mozambique and Balance of Payment (as % of service exports) of Swaziland?
Offer a very short reply. -28.86. In the year 2008, what is the difference between the Balance of Payment (as % of service exports) in Niger and Balance of Payment (as % of service exports) in Swaziland?
Ensure brevity in your answer.  -29.92. In the year 2009, what is the difference between the Balance of Payment (as % of service exports) in Luxembourg and Balance of Payment (as % of service exports) in Mozambique?
Provide a succinct answer. -8.75. In the year 2009, what is the difference between the Balance of Payment (as % of service exports) of Luxembourg and Balance of Payment (as % of service exports) of Niger?
Your response must be concise. -3.7. In the year 2009, what is the difference between the Balance of Payment (as % of service exports) in Luxembourg and Balance of Payment (as % of service exports) in Swaziland?
Make the answer very short. -29.72. In the year 2009, what is the difference between the Balance of Payment (as % of service exports) of Mozambique and Balance of Payment (as % of service exports) of Niger?
Provide a short and direct response. 5.05. In the year 2009, what is the difference between the Balance of Payment (as % of service exports) of Mozambique and Balance of Payment (as % of service exports) of Swaziland?
Keep it short and to the point. -20.96. In the year 2009, what is the difference between the Balance of Payment (as % of service exports) of Niger and Balance of Payment (as % of service exports) of Swaziland?
Ensure brevity in your answer.  -26.02. In the year 2010, what is the difference between the Balance of Payment (as % of service exports) in Luxembourg and Balance of Payment (as % of service exports) in Mozambique?
Offer a very short reply. -12.22. In the year 2010, what is the difference between the Balance of Payment (as % of service exports) of Luxembourg and Balance of Payment (as % of service exports) of Niger?
Your answer should be very brief. 12.11. In the year 2010, what is the difference between the Balance of Payment (as % of service exports) in Luxembourg and Balance of Payment (as % of service exports) in Swaziland?
Provide a succinct answer. -11.42. In the year 2010, what is the difference between the Balance of Payment (as % of service exports) of Mozambique and Balance of Payment (as % of service exports) of Niger?
Your response must be concise. 24.32. In the year 2010, what is the difference between the Balance of Payment (as % of service exports) of Mozambique and Balance of Payment (as % of service exports) of Swaziland?
Make the answer very short. 0.8. In the year 2010, what is the difference between the Balance of Payment (as % of service exports) in Niger and Balance of Payment (as % of service exports) in Swaziland?
Offer a terse response. -23.53. In the year 2011, what is the difference between the Balance of Payment (as % of service exports) in Luxembourg and Balance of Payment (as % of service exports) in Mozambique?
Ensure brevity in your answer.  -5.34. In the year 2011, what is the difference between the Balance of Payment (as % of service exports) of Luxembourg and Balance of Payment (as % of service exports) of Niger?
Ensure brevity in your answer.  3.3. In the year 2011, what is the difference between the Balance of Payment (as % of service exports) of Luxembourg and Balance of Payment (as % of service exports) of Swaziland?
Your answer should be very brief. -28.93. In the year 2011, what is the difference between the Balance of Payment (as % of service exports) of Mozambique and Balance of Payment (as % of service exports) of Niger?
Offer a terse response. 8.65. In the year 2011, what is the difference between the Balance of Payment (as % of service exports) in Mozambique and Balance of Payment (as % of service exports) in Swaziland?
Offer a very short reply. -23.59. In the year 2011, what is the difference between the Balance of Payment (as % of service exports) in Niger and Balance of Payment (as % of service exports) in Swaziland?
Ensure brevity in your answer.  -32.23. What is the ratio of the Balance of Payment (as % of service exports) of Luxembourg in 2005 to that in 2006?
Your answer should be compact. 1.13. What is the ratio of the Balance of Payment (as % of service exports) of Niger in 2005 to that in 2006?
Your response must be concise. 0.91. What is the ratio of the Balance of Payment (as % of service exports) in Swaziland in 2005 to that in 2006?
Make the answer very short. 0.29. What is the ratio of the Balance of Payment (as % of service exports) in Luxembourg in 2005 to that in 2007?
Provide a succinct answer. 1.07. What is the ratio of the Balance of Payment (as % of service exports) of Mozambique in 2005 to that in 2007?
Your response must be concise. 1.09. What is the ratio of the Balance of Payment (as % of service exports) of Niger in 2005 to that in 2007?
Your response must be concise. 1.4. What is the ratio of the Balance of Payment (as % of service exports) of Swaziland in 2005 to that in 2007?
Provide a short and direct response. 0.2. What is the ratio of the Balance of Payment (as % of service exports) in Luxembourg in 2005 to that in 2008?
Your answer should be compact. 0.91. What is the ratio of the Balance of Payment (as % of service exports) in Mozambique in 2005 to that in 2008?
Give a very brief answer. 0.99. What is the ratio of the Balance of Payment (as % of service exports) in Niger in 2005 to that in 2008?
Provide a short and direct response. 1.74. What is the ratio of the Balance of Payment (as % of service exports) of Swaziland in 2005 to that in 2008?
Make the answer very short. 0.31. What is the ratio of the Balance of Payment (as % of service exports) in Luxembourg in 2005 to that in 2009?
Give a very brief answer. 0.76. What is the ratio of the Balance of Payment (as % of service exports) in Mozambique in 2005 to that in 2009?
Your answer should be compact. 0.73. What is the ratio of the Balance of Payment (as % of service exports) in Niger in 2005 to that in 2009?
Ensure brevity in your answer.  1.49. What is the ratio of the Balance of Payment (as % of service exports) in Swaziland in 2005 to that in 2009?
Offer a very short reply. 0.32. What is the ratio of the Balance of Payment (as % of service exports) in Luxembourg in 2005 to that in 2010?
Your answer should be compact. 0.85. What is the ratio of the Balance of Payment (as % of service exports) of Mozambique in 2005 to that in 2010?
Give a very brief answer. 0.69. What is the ratio of the Balance of Payment (as % of service exports) of Niger in 2005 to that in 2010?
Make the answer very short. 6.32. What is the ratio of the Balance of Payment (as % of service exports) of Swaziland in 2005 to that in 2010?
Provide a succinct answer. 0.54. What is the ratio of the Balance of Payment (as % of service exports) in Luxembourg in 2005 to that in 2011?
Keep it short and to the point. 0.82. What is the ratio of the Balance of Payment (as % of service exports) in Mozambique in 2005 to that in 2011?
Your answer should be compact. 0.88. What is the ratio of the Balance of Payment (as % of service exports) of Niger in 2005 to that in 2011?
Ensure brevity in your answer.  2.32. What is the ratio of the Balance of Payment (as % of service exports) of Swaziland in 2005 to that in 2011?
Offer a very short reply. 0.33. What is the ratio of the Balance of Payment (as % of service exports) in Luxembourg in 2006 to that in 2007?
Ensure brevity in your answer.  0.95. What is the ratio of the Balance of Payment (as % of service exports) of Mozambique in 2006 to that in 2007?
Offer a terse response. 1.09. What is the ratio of the Balance of Payment (as % of service exports) of Niger in 2006 to that in 2007?
Ensure brevity in your answer.  1.54. What is the ratio of the Balance of Payment (as % of service exports) in Swaziland in 2006 to that in 2007?
Your answer should be very brief. 0.71. What is the ratio of the Balance of Payment (as % of service exports) in Luxembourg in 2006 to that in 2008?
Make the answer very short. 0.81. What is the ratio of the Balance of Payment (as % of service exports) of Niger in 2006 to that in 2008?
Your response must be concise. 1.92. What is the ratio of the Balance of Payment (as % of service exports) in Swaziland in 2006 to that in 2008?
Ensure brevity in your answer.  1.08. What is the ratio of the Balance of Payment (as % of service exports) in Luxembourg in 2006 to that in 2009?
Offer a terse response. 0.68. What is the ratio of the Balance of Payment (as % of service exports) of Mozambique in 2006 to that in 2009?
Give a very brief answer. 0.73. What is the ratio of the Balance of Payment (as % of service exports) in Niger in 2006 to that in 2009?
Your answer should be very brief. 1.64. What is the ratio of the Balance of Payment (as % of service exports) of Swaziland in 2006 to that in 2009?
Ensure brevity in your answer.  1.09. What is the ratio of the Balance of Payment (as % of service exports) of Luxembourg in 2006 to that in 2010?
Your response must be concise. 0.75. What is the ratio of the Balance of Payment (as % of service exports) of Mozambique in 2006 to that in 2010?
Ensure brevity in your answer.  0.69. What is the ratio of the Balance of Payment (as % of service exports) of Niger in 2006 to that in 2010?
Offer a terse response. 6.97. What is the ratio of the Balance of Payment (as % of service exports) in Swaziland in 2006 to that in 2010?
Ensure brevity in your answer.  1.85. What is the ratio of the Balance of Payment (as % of service exports) of Luxembourg in 2006 to that in 2011?
Ensure brevity in your answer.  0.73. What is the ratio of the Balance of Payment (as % of service exports) of Mozambique in 2006 to that in 2011?
Provide a succinct answer. 0.88. What is the ratio of the Balance of Payment (as % of service exports) in Niger in 2006 to that in 2011?
Your response must be concise. 2.56. What is the ratio of the Balance of Payment (as % of service exports) in Swaziland in 2006 to that in 2011?
Your response must be concise. 1.14. What is the ratio of the Balance of Payment (as % of service exports) of Luxembourg in 2007 to that in 2008?
Your response must be concise. 0.85. What is the ratio of the Balance of Payment (as % of service exports) of Mozambique in 2007 to that in 2008?
Provide a short and direct response. 0.91. What is the ratio of the Balance of Payment (as % of service exports) of Niger in 2007 to that in 2008?
Make the answer very short. 1.24. What is the ratio of the Balance of Payment (as % of service exports) of Swaziland in 2007 to that in 2008?
Offer a terse response. 1.53. What is the ratio of the Balance of Payment (as % of service exports) of Luxembourg in 2007 to that in 2009?
Your answer should be compact. 0.72. What is the ratio of the Balance of Payment (as % of service exports) of Mozambique in 2007 to that in 2009?
Offer a terse response. 0.67. What is the ratio of the Balance of Payment (as % of service exports) of Niger in 2007 to that in 2009?
Ensure brevity in your answer.  1.06. What is the ratio of the Balance of Payment (as % of service exports) in Swaziland in 2007 to that in 2009?
Offer a terse response. 1.55. What is the ratio of the Balance of Payment (as % of service exports) of Luxembourg in 2007 to that in 2010?
Your answer should be very brief. 0.79. What is the ratio of the Balance of Payment (as % of service exports) in Mozambique in 2007 to that in 2010?
Keep it short and to the point. 0.63. What is the ratio of the Balance of Payment (as % of service exports) in Niger in 2007 to that in 2010?
Your answer should be compact. 4.52. What is the ratio of the Balance of Payment (as % of service exports) of Swaziland in 2007 to that in 2010?
Give a very brief answer. 2.63. What is the ratio of the Balance of Payment (as % of service exports) of Luxembourg in 2007 to that in 2011?
Offer a very short reply. 0.77. What is the ratio of the Balance of Payment (as % of service exports) in Mozambique in 2007 to that in 2011?
Your response must be concise. 0.81. What is the ratio of the Balance of Payment (as % of service exports) in Niger in 2007 to that in 2011?
Provide a short and direct response. 1.66. What is the ratio of the Balance of Payment (as % of service exports) in Swaziland in 2007 to that in 2011?
Your response must be concise. 1.62. What is the ratio of the Balance of Payment (as % of service exports) of Luxembourg in 2008 to that in 2009?
Provide a short and direct response. 0.84. What is the ratio of the Balance of Payment (as % of service exports) in Mozambique in 2008 to that in 2009?
Give a very brief answer. 0.74. What is the ratio of the Balance of Payment (as % of service exports) of Niger in 2008 to that in 2009?
Give a very brief answer. 0.85. What is the ratio of the Balance of Payment (as % of service exports) in Swaziland in 2008 to that in 2009?
Provide a short and direct response. 1.01. What is the ratio of the Balance of Payment (as % of service exports) in Luxembourg in 2008 to that in 2010?
Your response must be concise. 0.93. What is the ratio of the Balance of Payment (as % of service exports) of Mozambique in 2008 to that in 2010?
Keep it short and to the point. 0.7. What is the ratio of the Balance of Payment (as % of service exports) in Niger in 2008 to that in 2010?
Your answer should be compact. 3.63. What is the ratio of the Balance of Payment (as % of service exports) in Swaziland in 2008 to that in 2010?
Provide a short and direct response. 1.71. What is the ratio of the Balance of Payment (as % of service exports) of Luxembourg in 2008 to that in 2011?
Your answer should be compact. 0.9. What is the ratio of the Balance of Payment (as % of service exports) in Mozambique in 2008 to that in 2011?
Offer a terse response. 0.89. What is the ratio of the Balance of Payment (as % of service exports) in Niger in 2008 to that in 2011?
Make the answer very short. 1.34. What is the ratio of the Balance of Payment (as % of service exports) in Swaziland in 2008 to that in 2011?
Give a very brief answer. 1.06. What is the ratio of the Balance of Payment (as % of service exports) of Luxembourg in 2009 to that in 2010?
Make the answer very short. 1.11. What is the ratio of the Balance of Payment (as % of service exports) of Mozambique in 2009 to that in 2010?
Provide a short and direct response. 0.95. What is the ratio of the Balance of Payment (as % of service exports) in Niger in 2009 to that in 2010?
Make the answer very short. 4.25. What is the ratio of the Balance of Payment (as % of service exports) in Swaziland in 2009 to that in 2010?
Ensure brevity in your answer.  1.7. What is the ratio of the Balance of Payment (as % of service exports) of Luxembourg in 2009 to that in 2011?
Offer a very short reply. 1.07. What is the ratio of the Balance of Payment (as % of service exports) of Mozambique in 2009 to that in 2011?
Your answer should be compact. 1.2. What is the ratio of the Balance of Payment (as % of service exports) of Niger in 2009 to that in 2011?
Your response must be concise. 1.56. What is the ratio of the Balance of Payment (as % of service exports) of Swaziland in 2009 to that in 2011?
Your answer should be compact. 1.04. What is the ratio of the Balance of Payment (as % of service exports) in Luxembourg in 2010 to that in 2011?
Your response must be concise. 0.97. What is the ratio of the Balance of Payment (as % of service exports) of Mozambique in 2010 to that in 2011?
Offer a terse response. 1.27. What is the ratio of the Balance of Payment (as % of service exports) in Niger in 2010 to that in 2011?
Provide a short and direct response. 0.37. What is the ratio of the Balance of Payment (as % of service exports) in Swaziland in 2010 to that in 2011?
Your response must be concise. 0.62. What is the difference between the highest and the second highest Balance of Payment (as % of service exports) of Luxembourg?
Give a very brief answer. 1.33. What is the difference between the highest and the second highest Balance of Payment (as % of service exports) of Mozambique?
Offer a very short reply. 1.6. What is the difference between the highest and the second highest Balance of Payment (as % of service exports) in Niger?
Offer a very short reply. 3.55. What is the difference between the highest and the second highest Balance of Payment (as % of service exports) of Swaziland?
Your response must be concise. 22.4. What is the difference between the highest and the lowest Balance of Payment (as % of service exports) in Luxembourg?
Your answer should be very brief. 6.22. What is the difference between the highest and the lowest Balance of Payment (as % of service exports) in Mozambique?
Your answer should be very brief. 10.88. What is the difference between the highest and the lowest Balance of Payment (as % of service exports) in Niger?
Offer a very short reply. 32.46. What is the difference between the highest and the lowest Balance of Payment (as % of service exports) in Swaziland?
Make the answer very short. 60.46. 